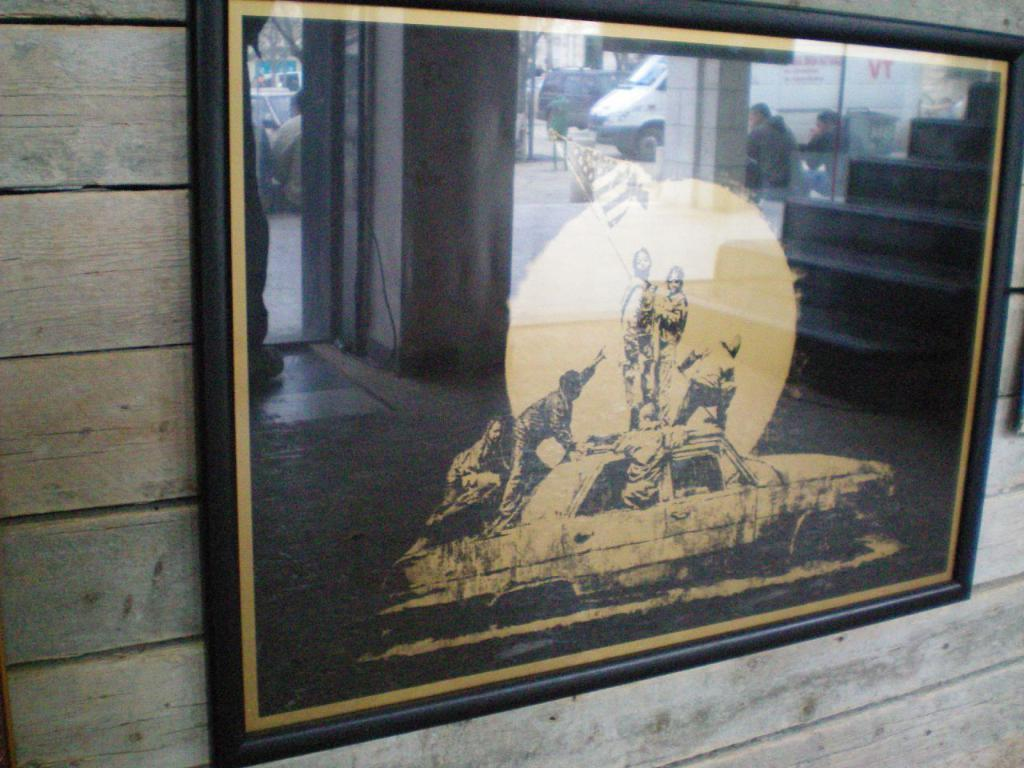What is the main subject of the image? There is a painting in the image. Where is the painting located? The painting is attached to a wall. What is the painting depicting? The painting depicts a car. What are the persons in the painting doing? The persons in the painting are standing on the car and holding flags. Is there a tent visible in the painting? No, there is no tent present in the painting. The painting only depicts a car with persons standing on it and holding flags. 